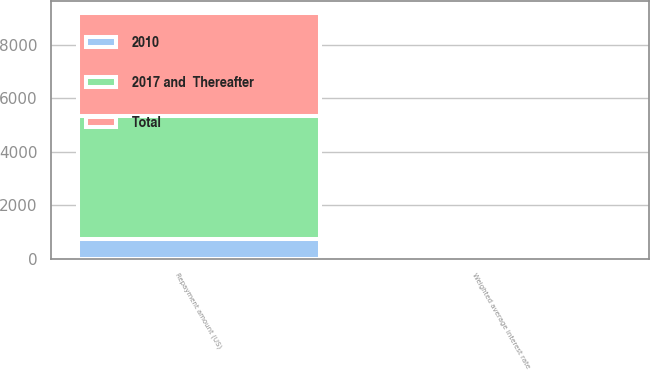Convert chart. <chart><loc_0><loc_0><loc_500><loc_500><stacked_bar_chart><ecel><fcel>Repayment amount (US)<fcel>Weighted average interest rate<nl><fcel>2010<fcel>750<fcel>5.5<nl><fcel>Total<fcel>3834<fcel>6.9<nl><fcel>2017 and  Thereafter<fcel>4584<fcel>6.6<nl></chart> 